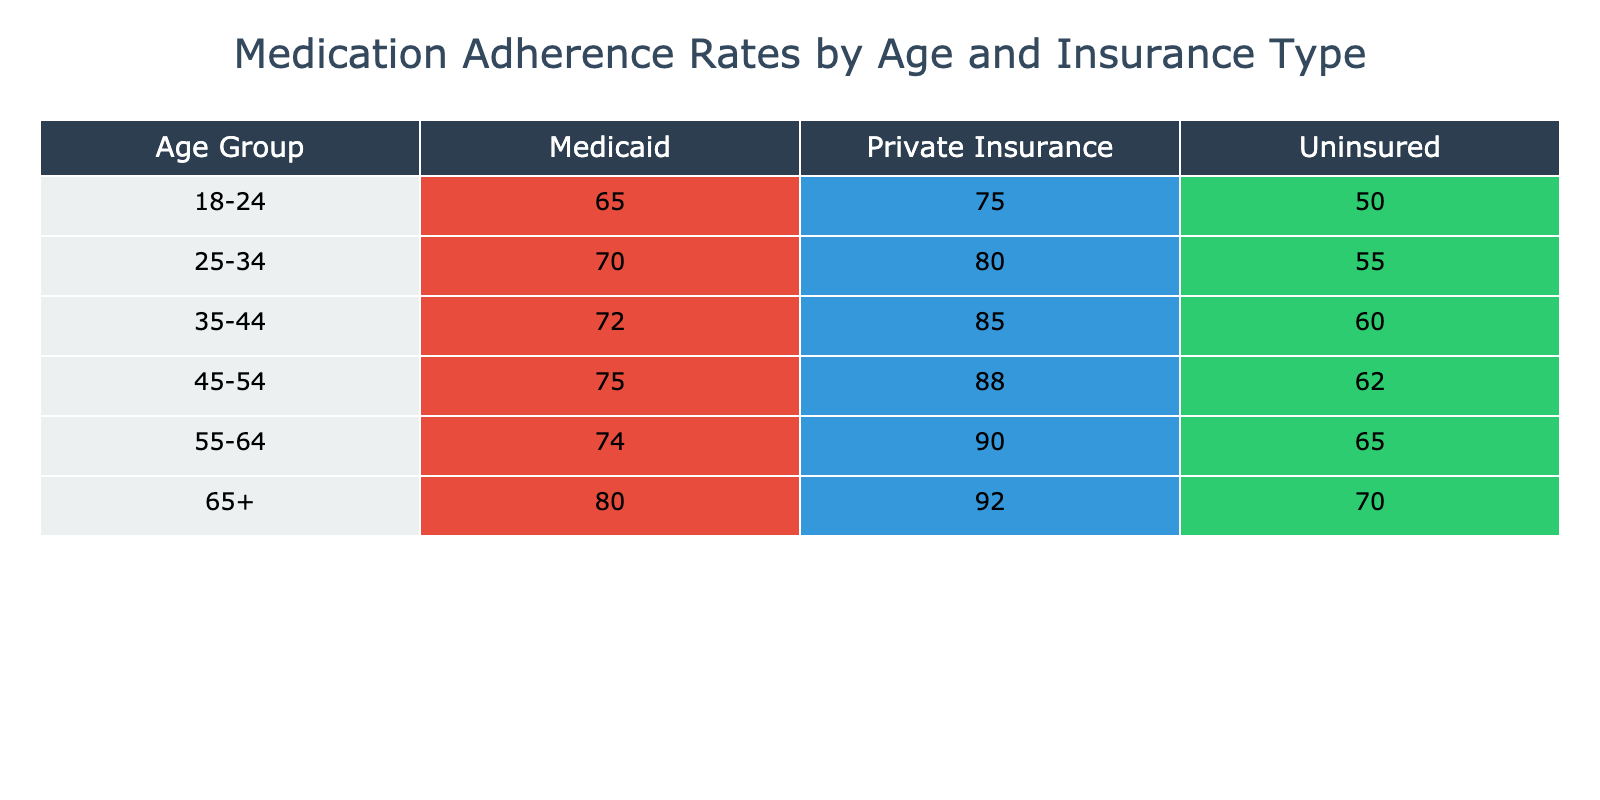What is the adherence rate for individuals aged 25-34 with Private Insurance? Referring to the table, we can locate the row corresponding to the age group 25-34 and the column for Private Insurance. The adherence rate listed there is 80%.
Answer: 80% What is the lowest medication adherence rate across all age groups and insurance types? To find the lowest adherence rate, we need to examine all values in the table. The lowest value listed is 50%, associated with the age group 18-24 and the Uninsured category.
Answer: 50% Is the adherence rate for Medicaid beneficiaries aged 45-54 higher than that for those aged 35-44? Looking at the rates for Medicaid beneficiaries, we see 75% for the 45-54 age group and 72% for the 35-44 age group. Since 75% is greater than 72%, the statement is true.
Answer: Yes What is the average medication adherence rate for those 65 and older? The adherence rates for the 65 and older group are 80% for Medicaid, 92% for Private Insurance, and 70% for Uninsured. To find the average, we sum these rates: 80 + 92 + 70 = 242. Then we divide by the number of entries, which is 3: 242 / 3 = 80.67%.
Answer: 80.67% Which insurance type has the highest adherence rate for the age group 55-64? By inspecting the table, we can see that the adherence rates for the 55-64 age group are 74% for Medicaid, 90% for Private Insurance, and 65% for Uninsured. The highest adherence rate is therefore 90%, associated with Private Insurance.
Answer: 90% How much higher is the adherence rate for Private Insurance compared to Uninsured for the age group 45-54? For the age group 45-54, the adherence rate for Private Insurance is 88%, whereas for Uninsured it is 62%. We calculate the difference: 88% - 62% = 26%. Thus, Private Insurance has an adherence rate that is 26% higher than Uninsured.
Answer: 26% What percentage of individuals aged 18-24 has inadequate medication adherence (defined as below 60%) with Medicaid? The adherence rate for individuals aged 18-24 with Medicaid is 65%. Since 65% is not below 60%, we conclude that none of the individuals in this category display inadequate adherence.
Answer: No Considering all age groups, which insurance type has the highest overall adherence rates and what is that rate? We need to review each age group and record the highest rates for each insurance type. The highest rates are Medicaid at 80% for 65+, Private Insurance at 92% for 65+, and Uninsured at 70% for 25-34. The highest overall adherence rate is thus 92% with Private Insurance.
Answer: 92% 